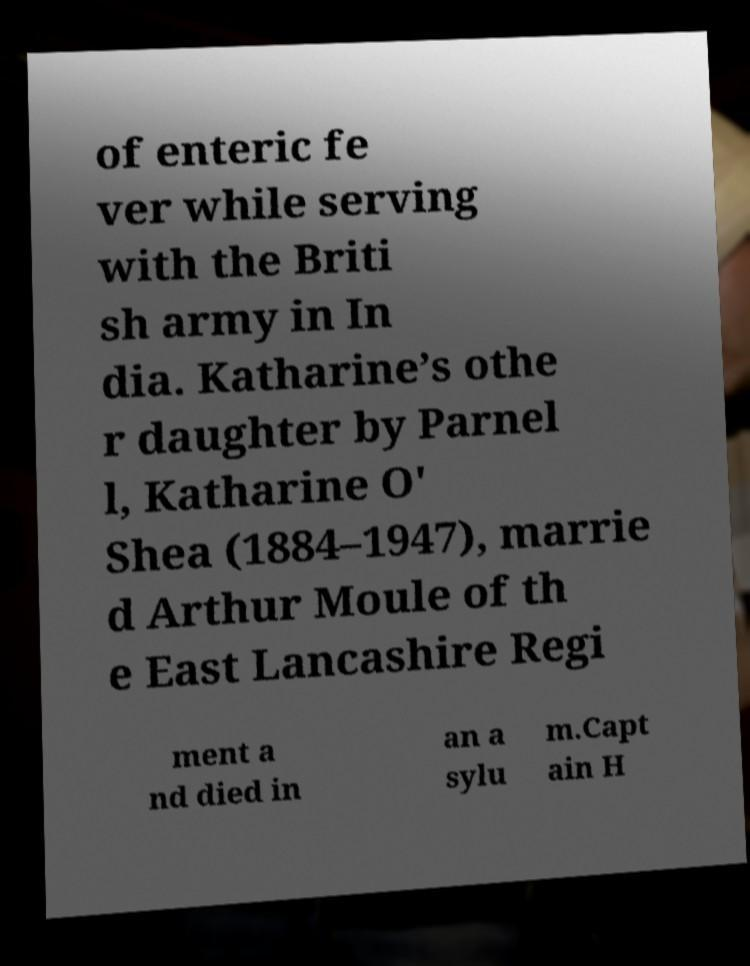Can you read and provide the text displayed in the image?This photo seems to have some interesting text. Can you extract and type it out for me? of enteric fe ver while serving with the Briti sh army in In dia. Katharine’s othe r daughter by Parnel l, Katharine O' Shea (1884–1947), marrie d Arthur Moule of th e East Lancashire Regi ment a nd died in an a sylu m.Capt ain H 